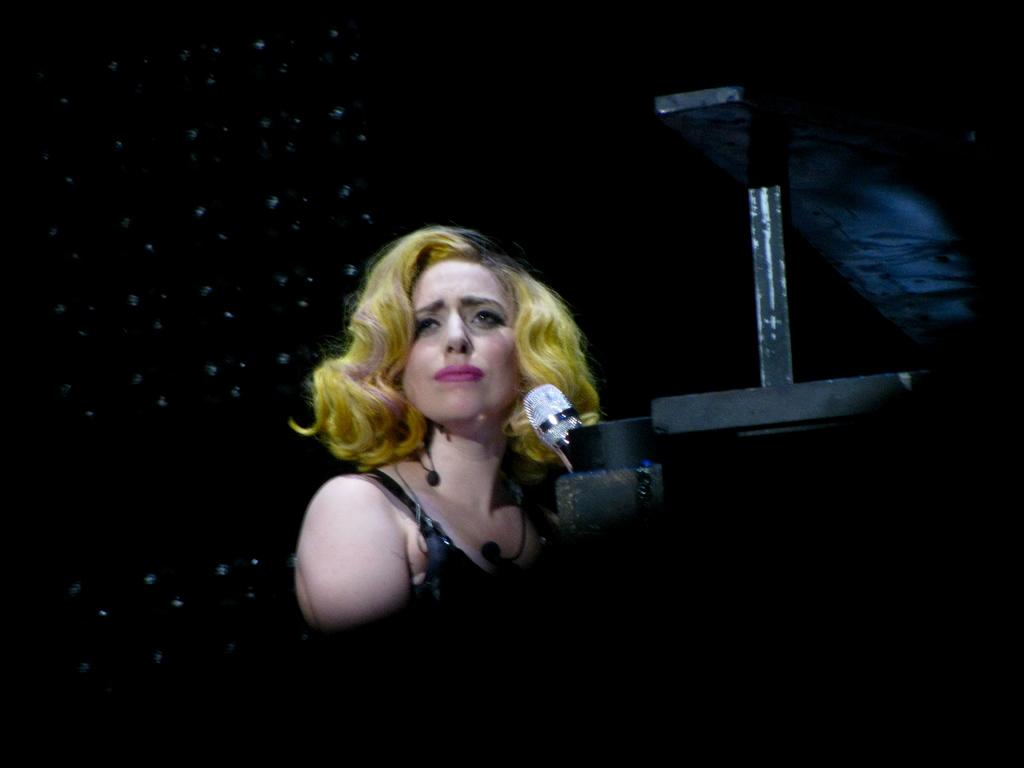Who is the main subject in the image? There is a woman in the image. What is the woman doing in the image? The woman is standing and holding a microphone. What can be seen in the background of the image? There is a black color screen in the background of the image. Is the woman using a hose to sneeze in the image? There is no hose or sneezing depicted in the image. The woman is holding a microphone and standing in front of a black color screen. 